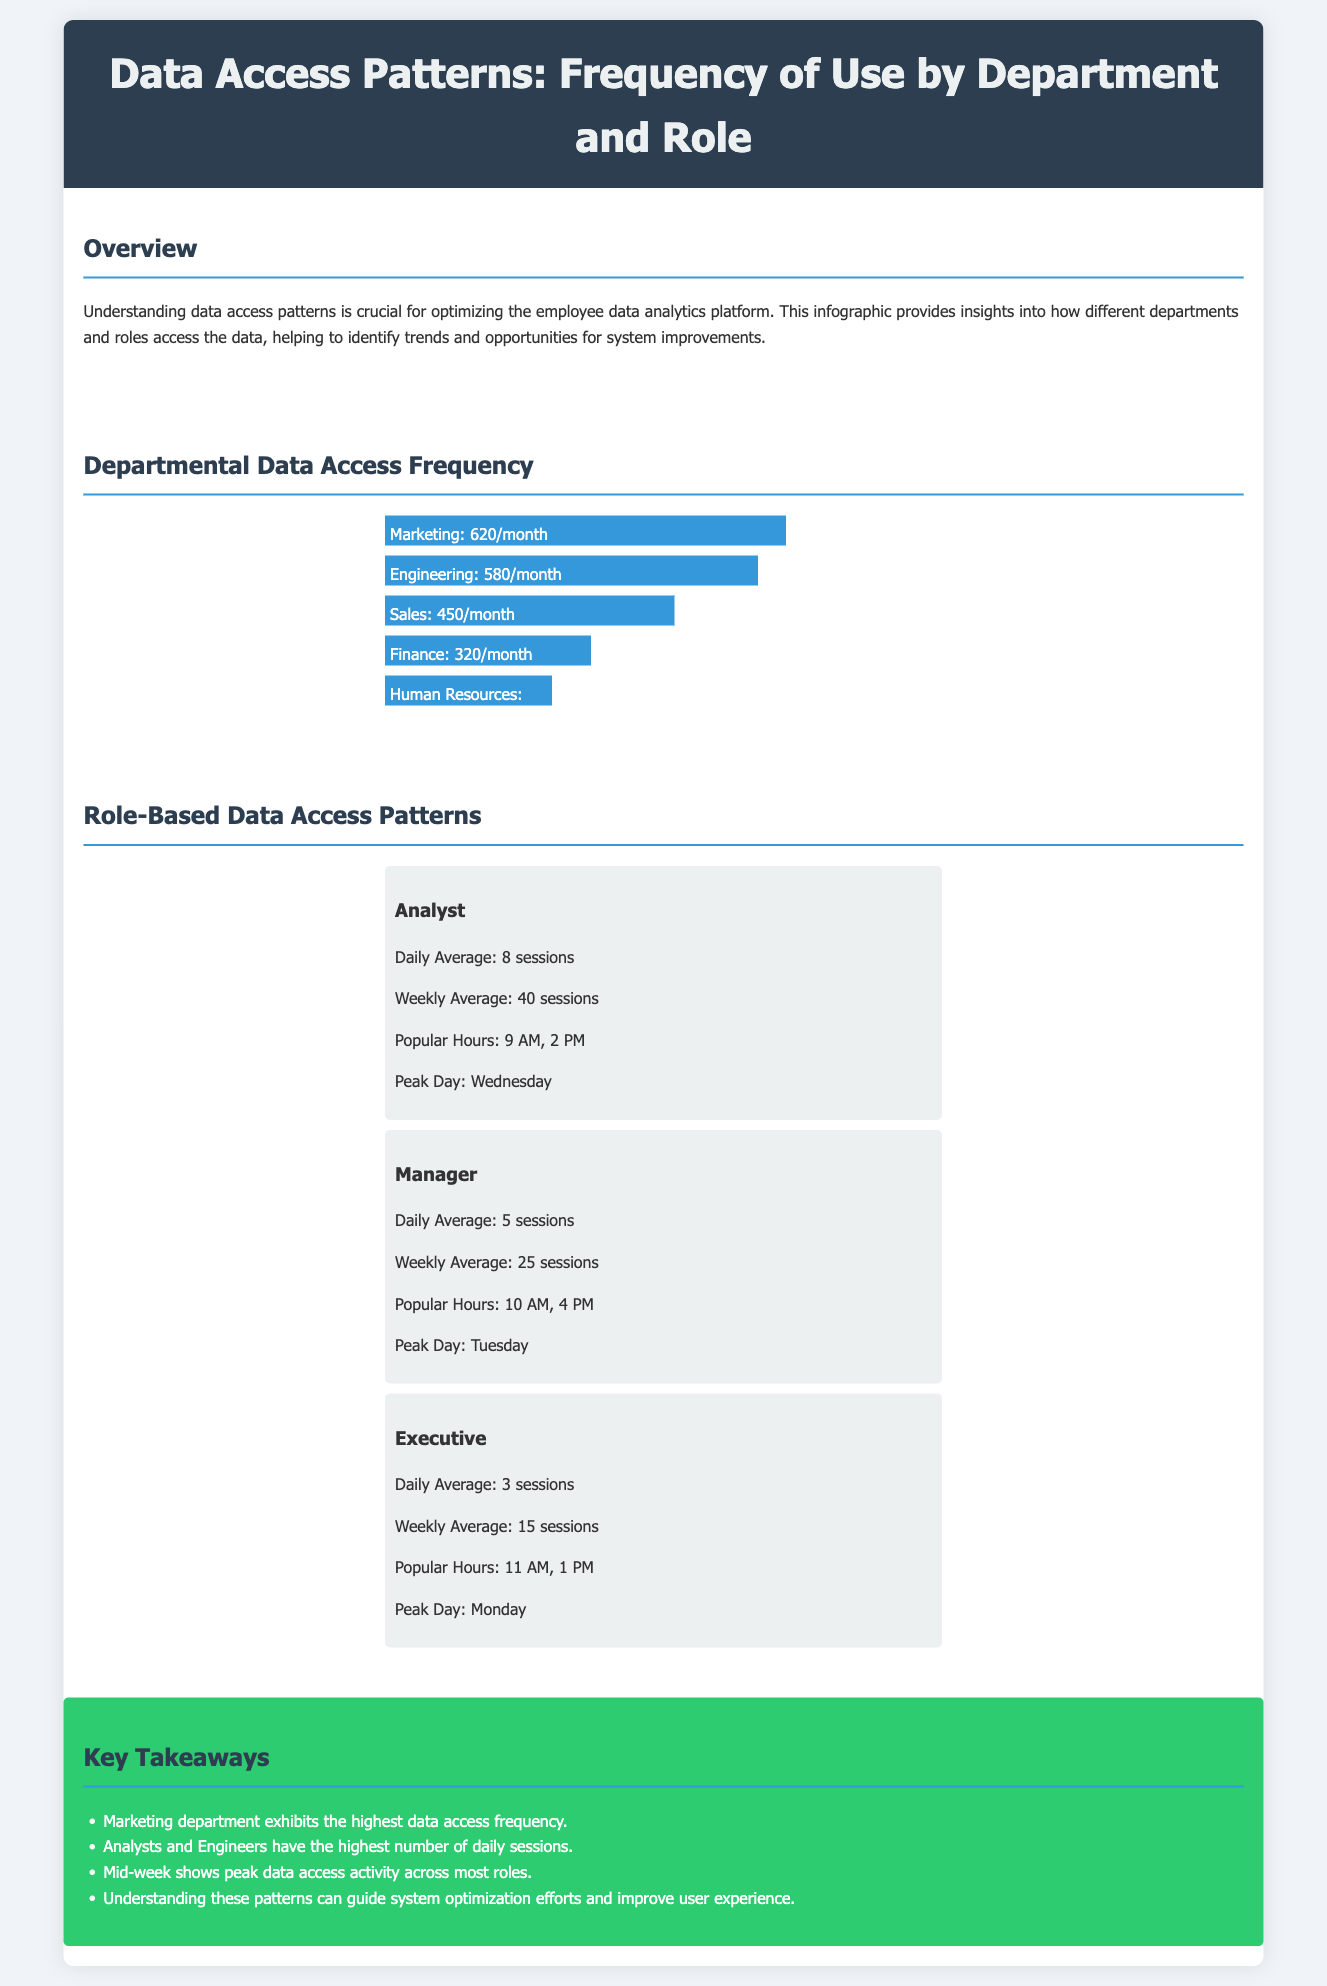What department has the highest data access frequency? The department with the highest data access frequency is Marketing, which has 620 accesses per month.
Answer: Marketing How many monthly data accesses does the Finance department have? The Finance department has 320 data accesses per month, as indicated in the infographic.
Answer: 320/month What is the daily average session number for Analysts? The daily average session number for Analysts is 8 sessions, as outlined in the Role-Based section.
Answer: 8 sessions Which day of the week is the peak access day for Managers? The peak access day for Managers is Tuesday, as stated in the infographic.
Answer: Tuesday What is the weekly average session number for Executives? The weekly average session number for Executives is 15 sessions.
Answer: 15 sessions Which department has the lowest data access frequency? The department with the lowest data access frequency is Human Resources, with 260 accesses per month.
Answer: Human Resources What are the popular hours for Analysts? The popular hours for Analysts are 9 AM and 2 PM, as listed under Role-Based Data Access Patterns.
Answer: 9 AM, 2 PM How many sessions do Managers average per week? Managers average 25 sessions per week, according to the Role-Based Data Access Patterns.
Answer: 25 sessions What color is used for the bar chart in the infographic? The bar chart is represented in blue, specifically the color code is #3498db.
Answer: Blue 